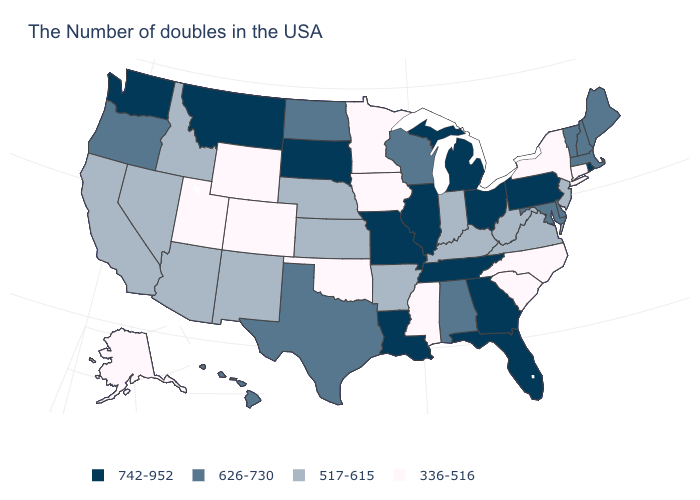Does Virginia have a lower value than Utah?
Be succinct. No. What is the value of New Hampshire?
Answer briefly. 626-730. Which states have the highest value in the USA?
Be succinct. Rhode Island, Pennsylvania, Ohio, Florida, Georgia, Michigan, Tennessee, Illinois, Louisiana, Missouri, South Dakota, Montana, Washington. Does Kentucky have a higher value than North Carolina?
Concise answer only. Yes. What is the value of Wyoming?
Write a very short answer. 336-516. Name the states that have a value in the range 742-952?
Keep it brief. Rhode Island, Pennsylvania, Ohio, Florida, Georgia, Michigan, Tennessee, Illinois, Louisiana, Missouri, South Dakota, Montana, Washington. What is the value of Colorado?
Give a very brief answer. 336-516. Among the states that border Kansas , does Missouri have the highest value?
Concise answer only. Yes. What is the lowest value in the USA?
Be succinct. 336-516. Does Georgia have the highest value in the South?
Give a very brief answer. Yes. What is the value of Minnesota?
Answer briefly. 336-516. What is the lowest value in the South?
Quick response, please. 336-516. Which states have the lowest value in the Northeast?
Answer briefly. Connecticut, New York. Name the states that have a value in the range 626-730?
Keep it brief. Maine, Massachusetts, New Hampshire, Vermont, Delaware, Maryland, Alabama, Wisconsin, Texas, North Dakota, Oregon, Hawaii. Does Kentucky have the lowest value in the South?
Quick response, please. No. 